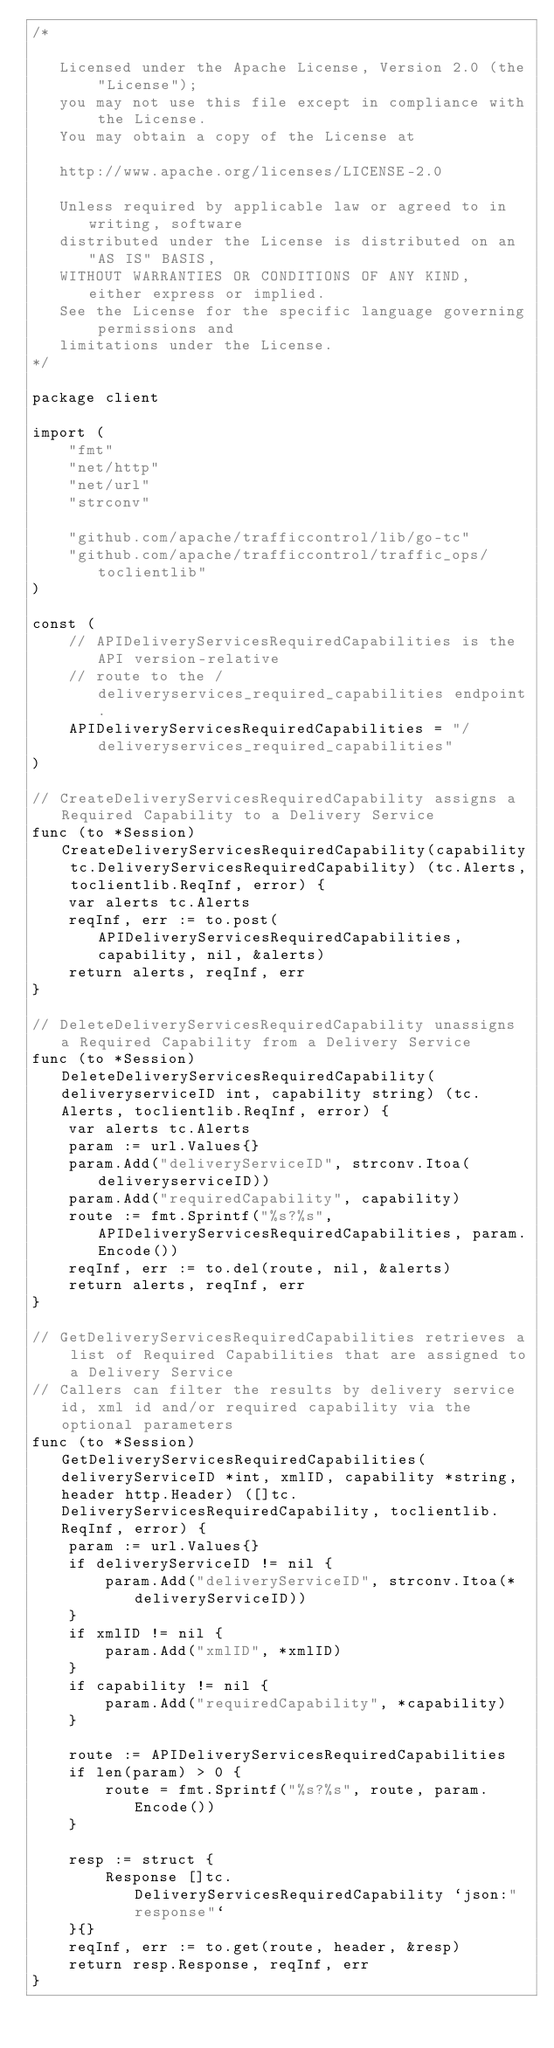<code> <loc_0><loc_0><loc_500><loc_500><_Go_>/*

   Licensed under the Apache License, Version 2.0 (the "License");
   you may not use this file except in compliance with the License.
   You may obtain a copy of the License at

   http://www.apache.org/licenses/LICENSE-2.0

   Unless required by applicable law or agreed to in writing, software
   distributed under the License is distributed on an "AS IS" BASIS,
   WITHOUT WARRANTIES OR CONDITIONS OF ANY KIND, either express or implied.
   See the License for the specific language governing permissions and
   limitations under the License.
*/

package client

import (
	"fmt"
	"net/http"
	"net/url"
	"strconv"

	"github.com/apache/trafficcontrol/lib/go-tc"
	"github.com/apache/trafficcontrol/traffic_ops/toclientlib"
)

const (
	// APIDeliveryServicesRequiredCapabilities is the API version-relative
	// route to the /deliveryservices_required_capabilities endpoint.
	APIDeliveryServicesRequiredCapabilities = "/deliveryservices_required_capabilities"
)

// CreateDeliveryServicesRequiredCapability assigns a Required Capability to a Delivery Service
func (to *Session) CreateDeliveryServicesRequiredCapability(capability tc.DeliveryServicesRequiredCapability) (tc.Alerts, toclientlib.ReqInf, error) {
	var alerts tc.Alerts
	reqInf, err := to.post(APIDeliveryServicesRequiredCapabilities, capability, nil, &alerts)
	return alerts, reqInf, err
}

// DeleteDeliveryServicesRequiredCapability unassigns a Required Capability from a Delivery Service
func (to *Session) DeleteDeliveryServicesRequiredCapability(deliveryserviceID int, capability string) (tc.Alerts, toclientlib.ReqInf, error) {
	var alerts tc.Alerts
	param := url.Values{}
	param.Add("deliveryServiceID", strconv.Itoa(deliveryserviceID))
	param.Add("requiredCapability", capability)
	route := fmt.Sprintf("%s?%s", APIDeliveryServicesRequiredCapabilities, param.Encode())
	reqInf, err := to.del(route, nil, &alerts)
	return alerts, reqInf, err
}

// GetDeliveryServicesRequiredCapabilities retrieves a list of Required Capabilities that are assigned to a Delivery Service
// Callers can filter the results by delivery service id, xml id and/or required capability via the optional parameters
func (to *Session) GetDeliveryServicesRequiredCapabilities(deliveryServiceID *int, xmlID, capability *string, header http.Header) ([]tc.DeliveryServicesRequiredCapability, toclientlib.ReqInf, error) {
	param := url.Values{}
	if deliveryServiceID != nil {
		param.Add("deliveryServiceID", strconv.Itoa(*deliveryServiceID))
	}
	if xmlID != nil {
		param.Add("xmlID", *xmlID)
	}
	if capability != nil {
		param.Add("requiredCapability", *capability)
	}

	route := APIDeliveryServicesRequiredCapabilities
	if len(param) > 0 {
		route = fmt.Sprintf("%s?%s", route, param.Encode())
	}

	resp := struct {
		Response []tc.DeliveryServicesRequiredCapability `json:"response"`
	}{}
	reqInf, err := to.get(route, header, &resp)
	return resp.Response, reqInf, err
}
</code> 